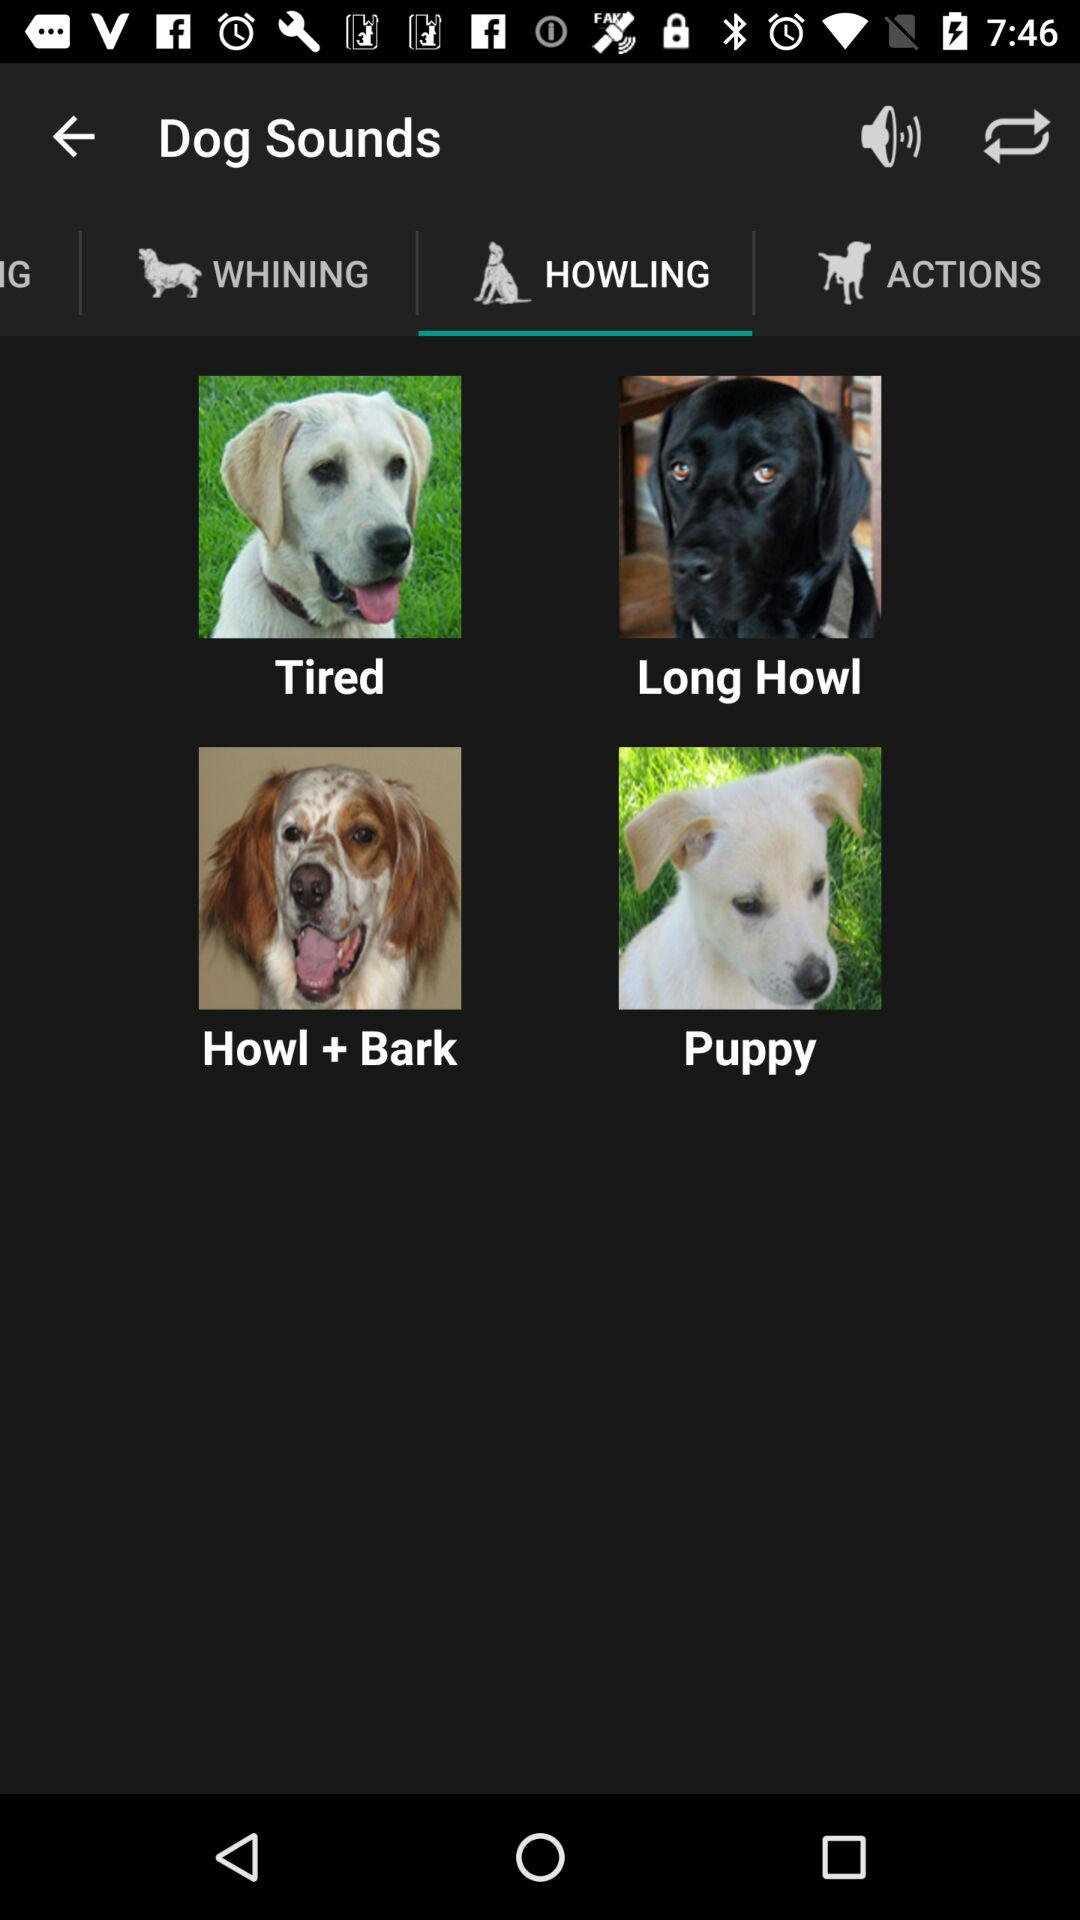What are the options given for "Dog Sounds"? The given options are "WHINING", "HOWLING", and "ACTIONS". 